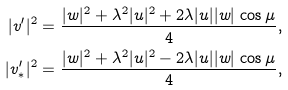<formula> <loc_0><loc_0><loc_500><loc_500>| v ^ { \prime } | ^ { 2 } & = \frac { | w | ^ { 2 } + \lambda ^ { 2 } | u | ^ { 2 } + 2 \lambda | u | | w | \, \cos \mu } { 4 } , \\ | v ^ { \prime } _ { * } | ^ { 2 } & = \frac { | w | ^ { 2 } + \lambda ^ { 2 } | u | ^ { 2 } - 2 \lambda | u | | w | \, \cos \mu } { 4 } ,</formula> 